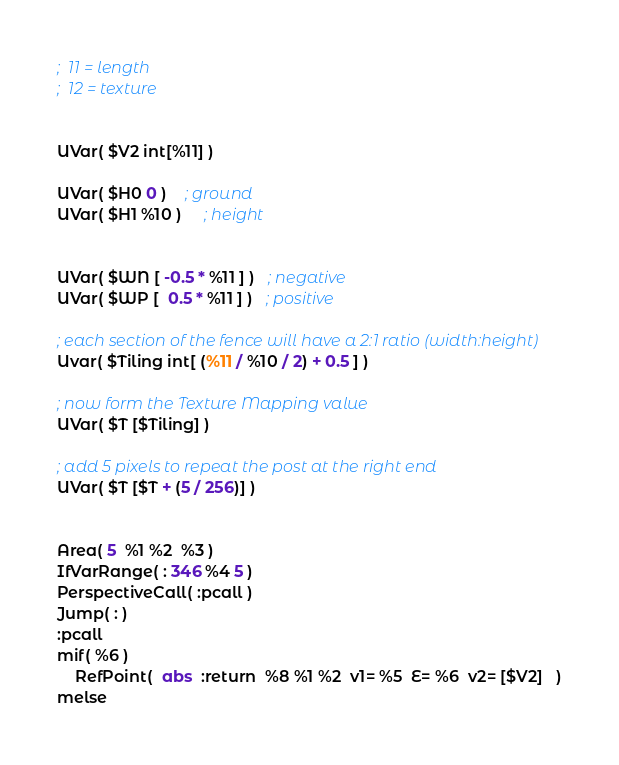<code> <loc_0><loc_0><loc_500><loc_500><_Scheme_>;  11 = length
;  12 = texture


UVar( $V2 int[%11] )

UVar( $H0 0 )    ; ground
UVar( $H1 %10 )	 ; height	


UVar( $WN [ -0.5 * %11 ] )   ; negative
UVar( $WP [  0.5 * %11 ] )   ; positive

; each section of the fence will have a 2:1 ratio (width:height)
Uvar( $Tiling int[ (%11 / %10 / 2) + 0.5 ] )

; now form the Texture Mapping value
UVar( $T [$Tiling] )

; add 5 pixels to repeat the post at the right end
UVar( $T [$T + (5 / 256)] )


Area( 5  %1 %2  %3 )
IfVarRange( : 346 %4 5 )
PerspectiveCall( :pcall )
Jump( : )
:pcall
mif( %6 )
	RefPoint(  abs  :return  %8 %1 %2  v1= %5  E= %6  v2= [$V2]   )
melse</code> 